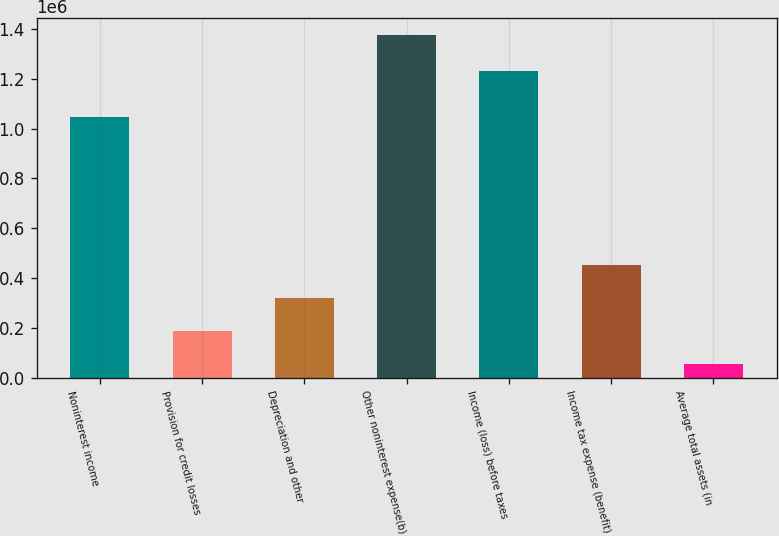Convert chart to OTSL. <chart><loc_0><loc_0><loc_500><loc_500><bar_chart><fcel>Noninterest income<fcel>Provision for credit losses<fcel>Depreciation and other<fcel>Other noninterest expense(b)<fcel>Income (loss) before taxes<fcel>Income tax expense (benefit)<fcel>Average total assets (in<nl><fcel>1.04585e+06<fcel>187837<fcel>319835<fcel>1.37582e+06<fcel>1.23164e+06<fcel>451833<fcel>55839<nl></chart> 